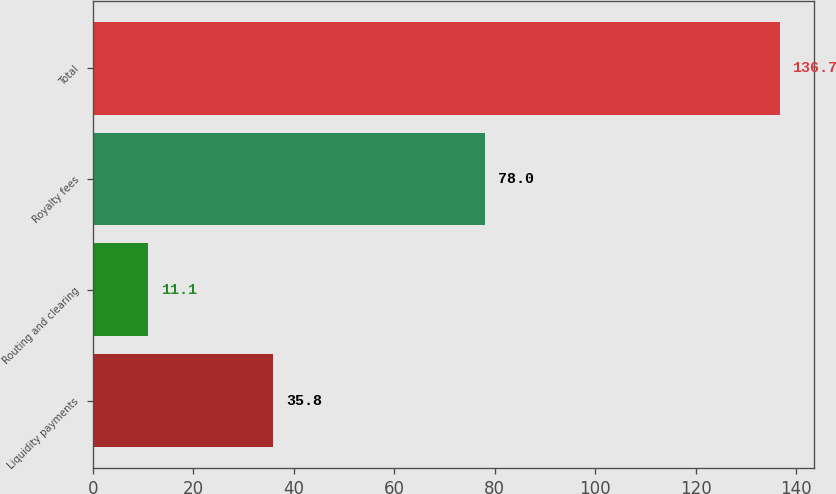<chart> <loc_0><loc_0><loc_500><loc_500><bar_chart><fcel>Liquidity payments<fcel>Routing and clearing<fcel>Royalty fees<fcel>Total<nl><fcel>35.8<fcel>11.1<fcel>78<fcel>136.7<nl></chart> 